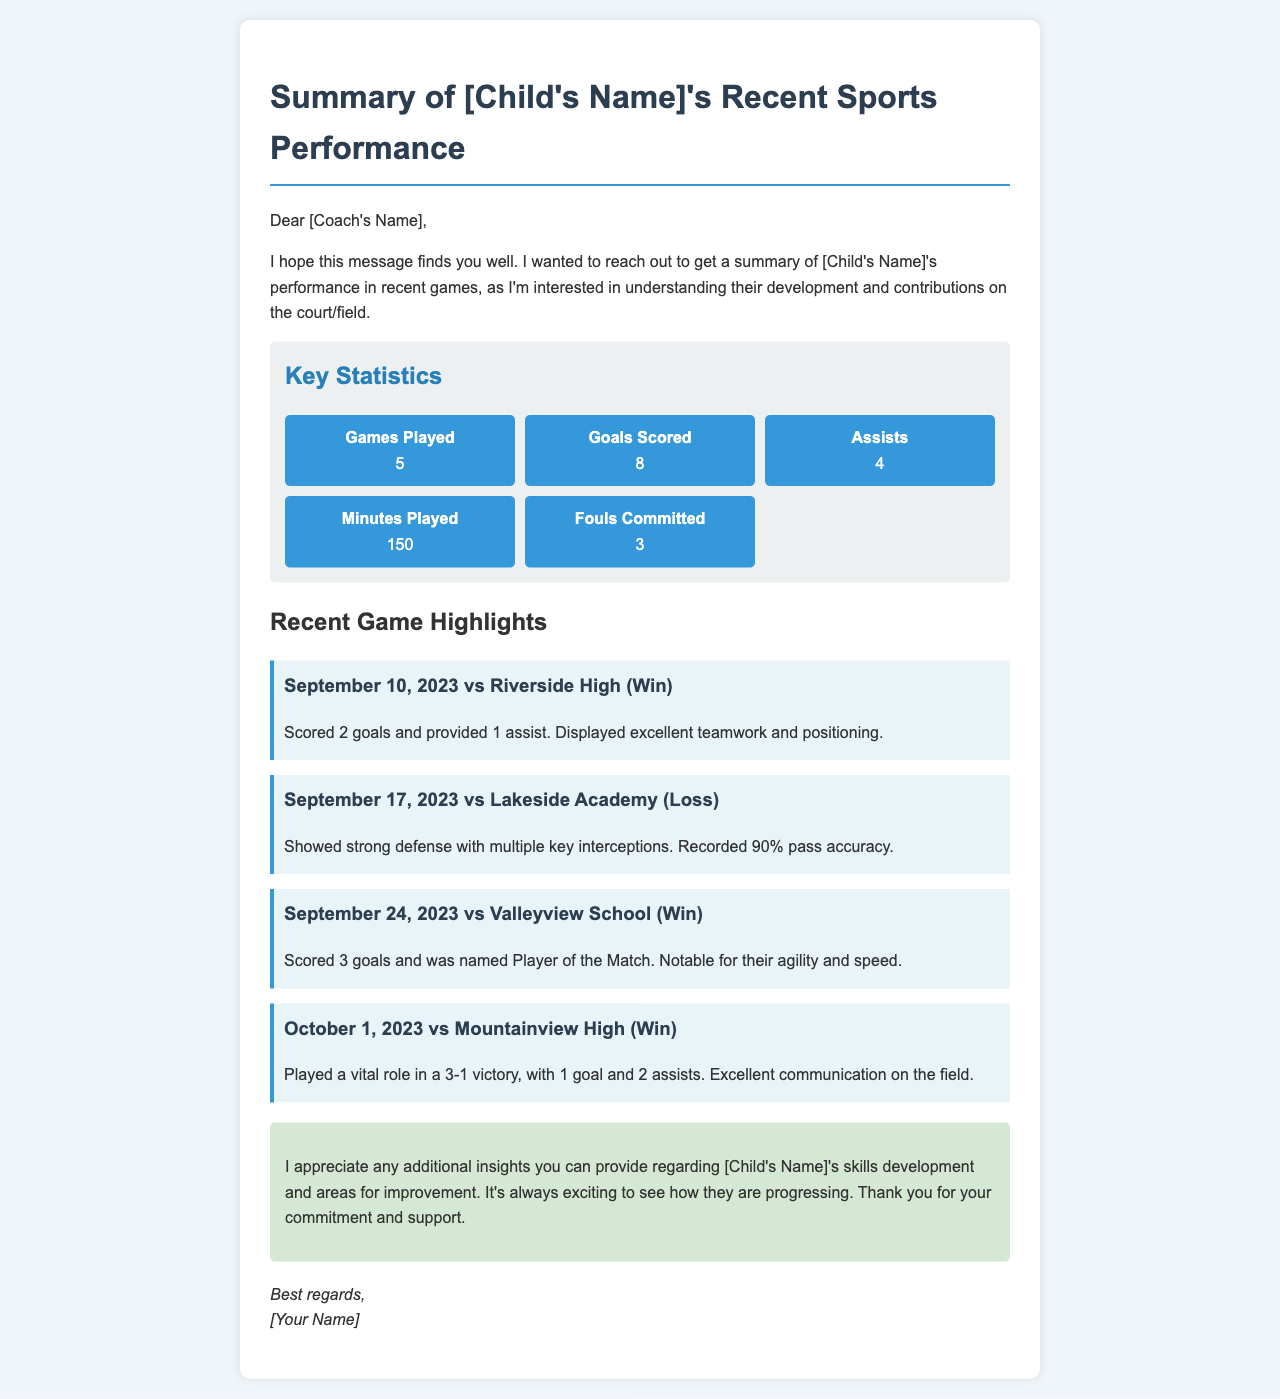What is the name of the child? The child's name is denoted as [Child's Name] in the document.
Answer: [Child's Name] How many games has [Child's Name] played? The document states that [Child's Name] has played 5 games.
Answer: 5 What is the total number of goals scored by [Child's Name]? The summary lists that [Child's Name] has scored a total of 8 goals.
Answer: 8 Which game did [Child's Name] score the most goals? The highlight for the game on September 24, 2023, indicates [Child's Name] scored 3 goals.
Answer: September 24, 2023 vs Valleyview School What was [Child's Name]'s pass accuracy in the game against Lakeside Academy? The document mentions a 90% pass accuracy for the game against Lakeside Academy.
Answer: 90% In how many wins did [Child's Name] participate? The highlights show [Child's Name] participated in 4 wins.
Answer: 4 What is the date of the first game summarized in the document? The first highlighted game date is September 10, 2023.
Answer: September 10, 2023 What feedback is requested from the coach? The email asks for additional insights on skills development and areas for improvement.
Answer: Insights on skills development and areas for improvement Who is the author of the email? The document includes a placeholder for the author's name as [Your Name].
Answer: [Your Name] 